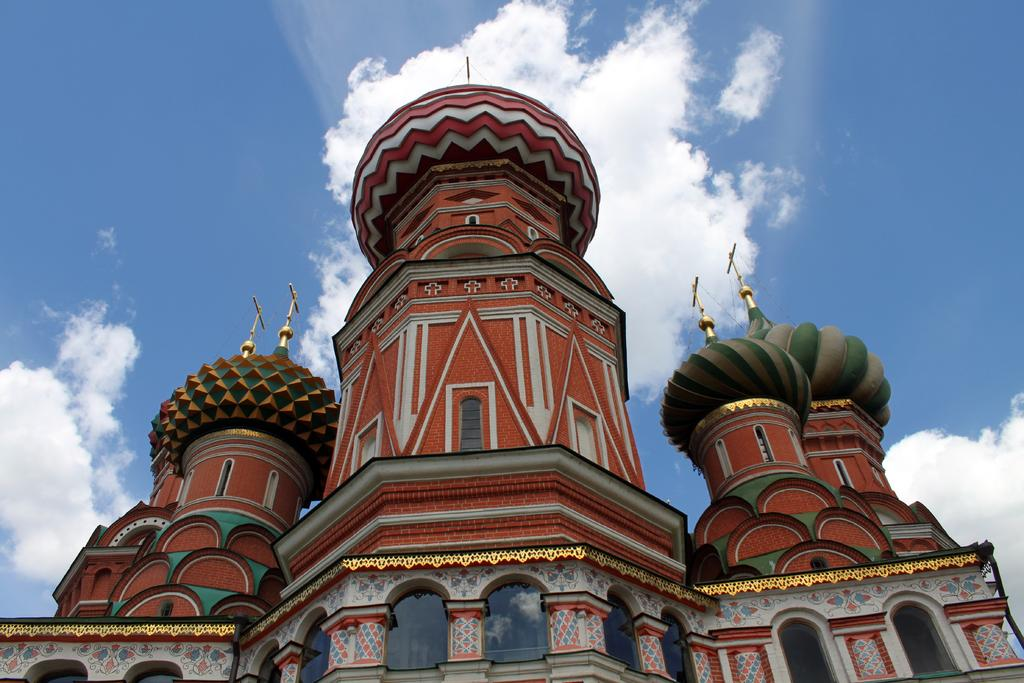What type of building is in the image? There is a palace in the image. What part of the natural environment can be seen in the image? The sky is visible in the image. What instrument is the fireman playing in the image? There is no fireman or instrument present in the image. How many trees are visible in the image? There is no tree visible in the image; only the palace and sky are present. 